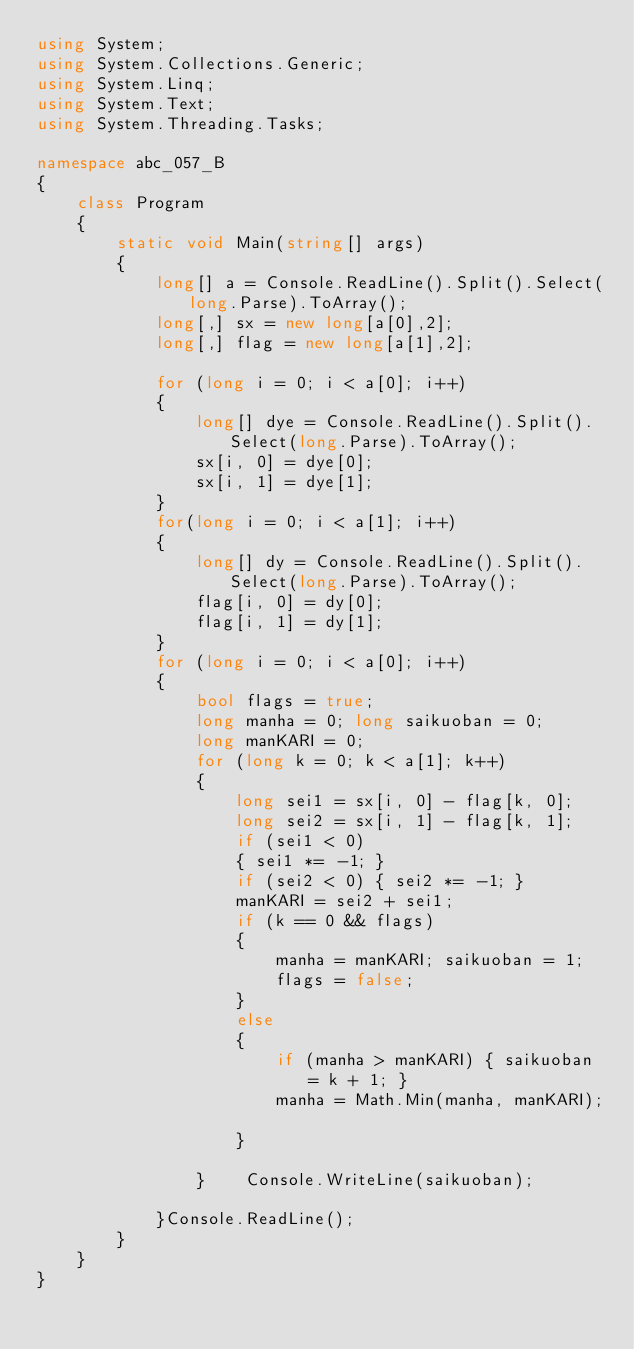<code> <loc_0><loc_0><loc_500><loc_500><_C#_>using System;
using System.Collections.Generic;
using System.Linq;
using System.Text;
using System.Threading.Tasks;

namespace abc_057_B
{
    class Program
    {
        static void Main(string[] args)
        {
            long[] a = Console.ReadLine().Split().Select(long.Parse).ToArray();
            long[,] sx = new long[a[0],2];
            long[,] flag = new long[a[1],2];

            for (long i = 0; i < a[0]; i++)
            {
                long[] dye = Console.ReadLine().Split().Select(long.Parse).ToArray();
                sx[i, 0] = dye[0];
                sx[i, 1] = dye[1];
            }
            for(long i = 0; i < a[1]; i++)
            {
                long[] dy = Console.ReadLine().Split().Select(long.Parse).ToArray();
                flag[i, 0] = dy[0];
                flag[i, 1] = dy[1];
            }
            for (long i = 0; i < a[0]; i++)
            {
                bool flags = true;
                long manha = 0; long saikuoban = 0;
                long manKARI = 0;
                for (long k = 0; k < a[1]; k++)
                {
                    long sei1 = sx[i, 0] - flag[k, 0];
                    long sei2 = sx[i, 1] - flag[k, 1];
                    if (sei1 < 0)
                    { sei1 *= -1; }
                    if (sei2 < 0) { sei2 *= -1; }
                    manKARI = sei2 + sei1;
                    if (k == 0 && flags)
                    {
                        manha = manKARI; saikuoban = 1;
                        flags = false;
                    }
                    else
                    {
                        if (manha > manKARI) { saikuoban = k + 1; }
                        manha = Math.Min(manha, manKARI);

                    }

                }    Console.WriteLine(saikuoban);
                
            }Console.ReadLine();
        }
    }
}
</code> 